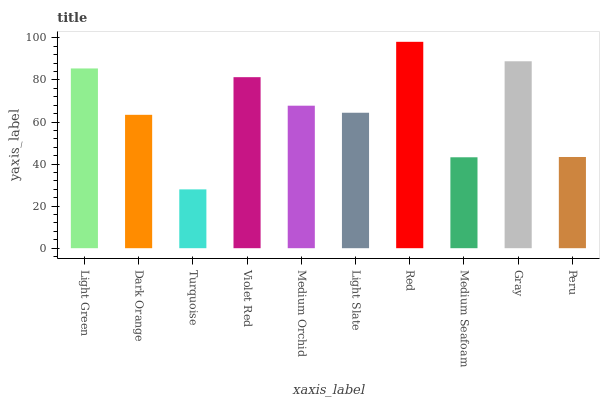Is Turquoise the minimum?
Answer yes or no. Yes. Is Red the maximum?
Answer yes or no. Yes. Is Dark Orange the minimum?
Answer yes or no. No. Is Dark Orange the maximum?
Answer yes or no. No. Is Light Green greater than Dark Orange?
Answer yes or no. Yes. Is Dark Orange less than Light Green?
Answer yes or no. Yes. Is Dark Orange greater than Light Green?
Answer yes or no. No. Is Light Green less than Dark Orange?
Answer yes or no. No. Is Medium Orchid the high median?
Answer yes or no. Yes. Is Light Slate the low median?
Answer yes or no. Yes. Is Violet Red the high median?
Answer yes or no. No. Is Violet Red the low median?
Answer yes or no. No. 